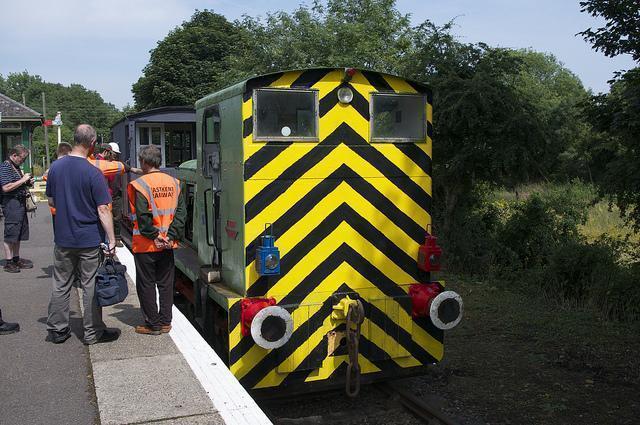Why are the men wearing orange vests?
Select the accurate answer and provide justification: `Answer: choice
Rationale: srationale.`
Options: Camouflage, fashion, dress code, visibility. Answer: visibility.
Rationale: The orange vests are for safety. 